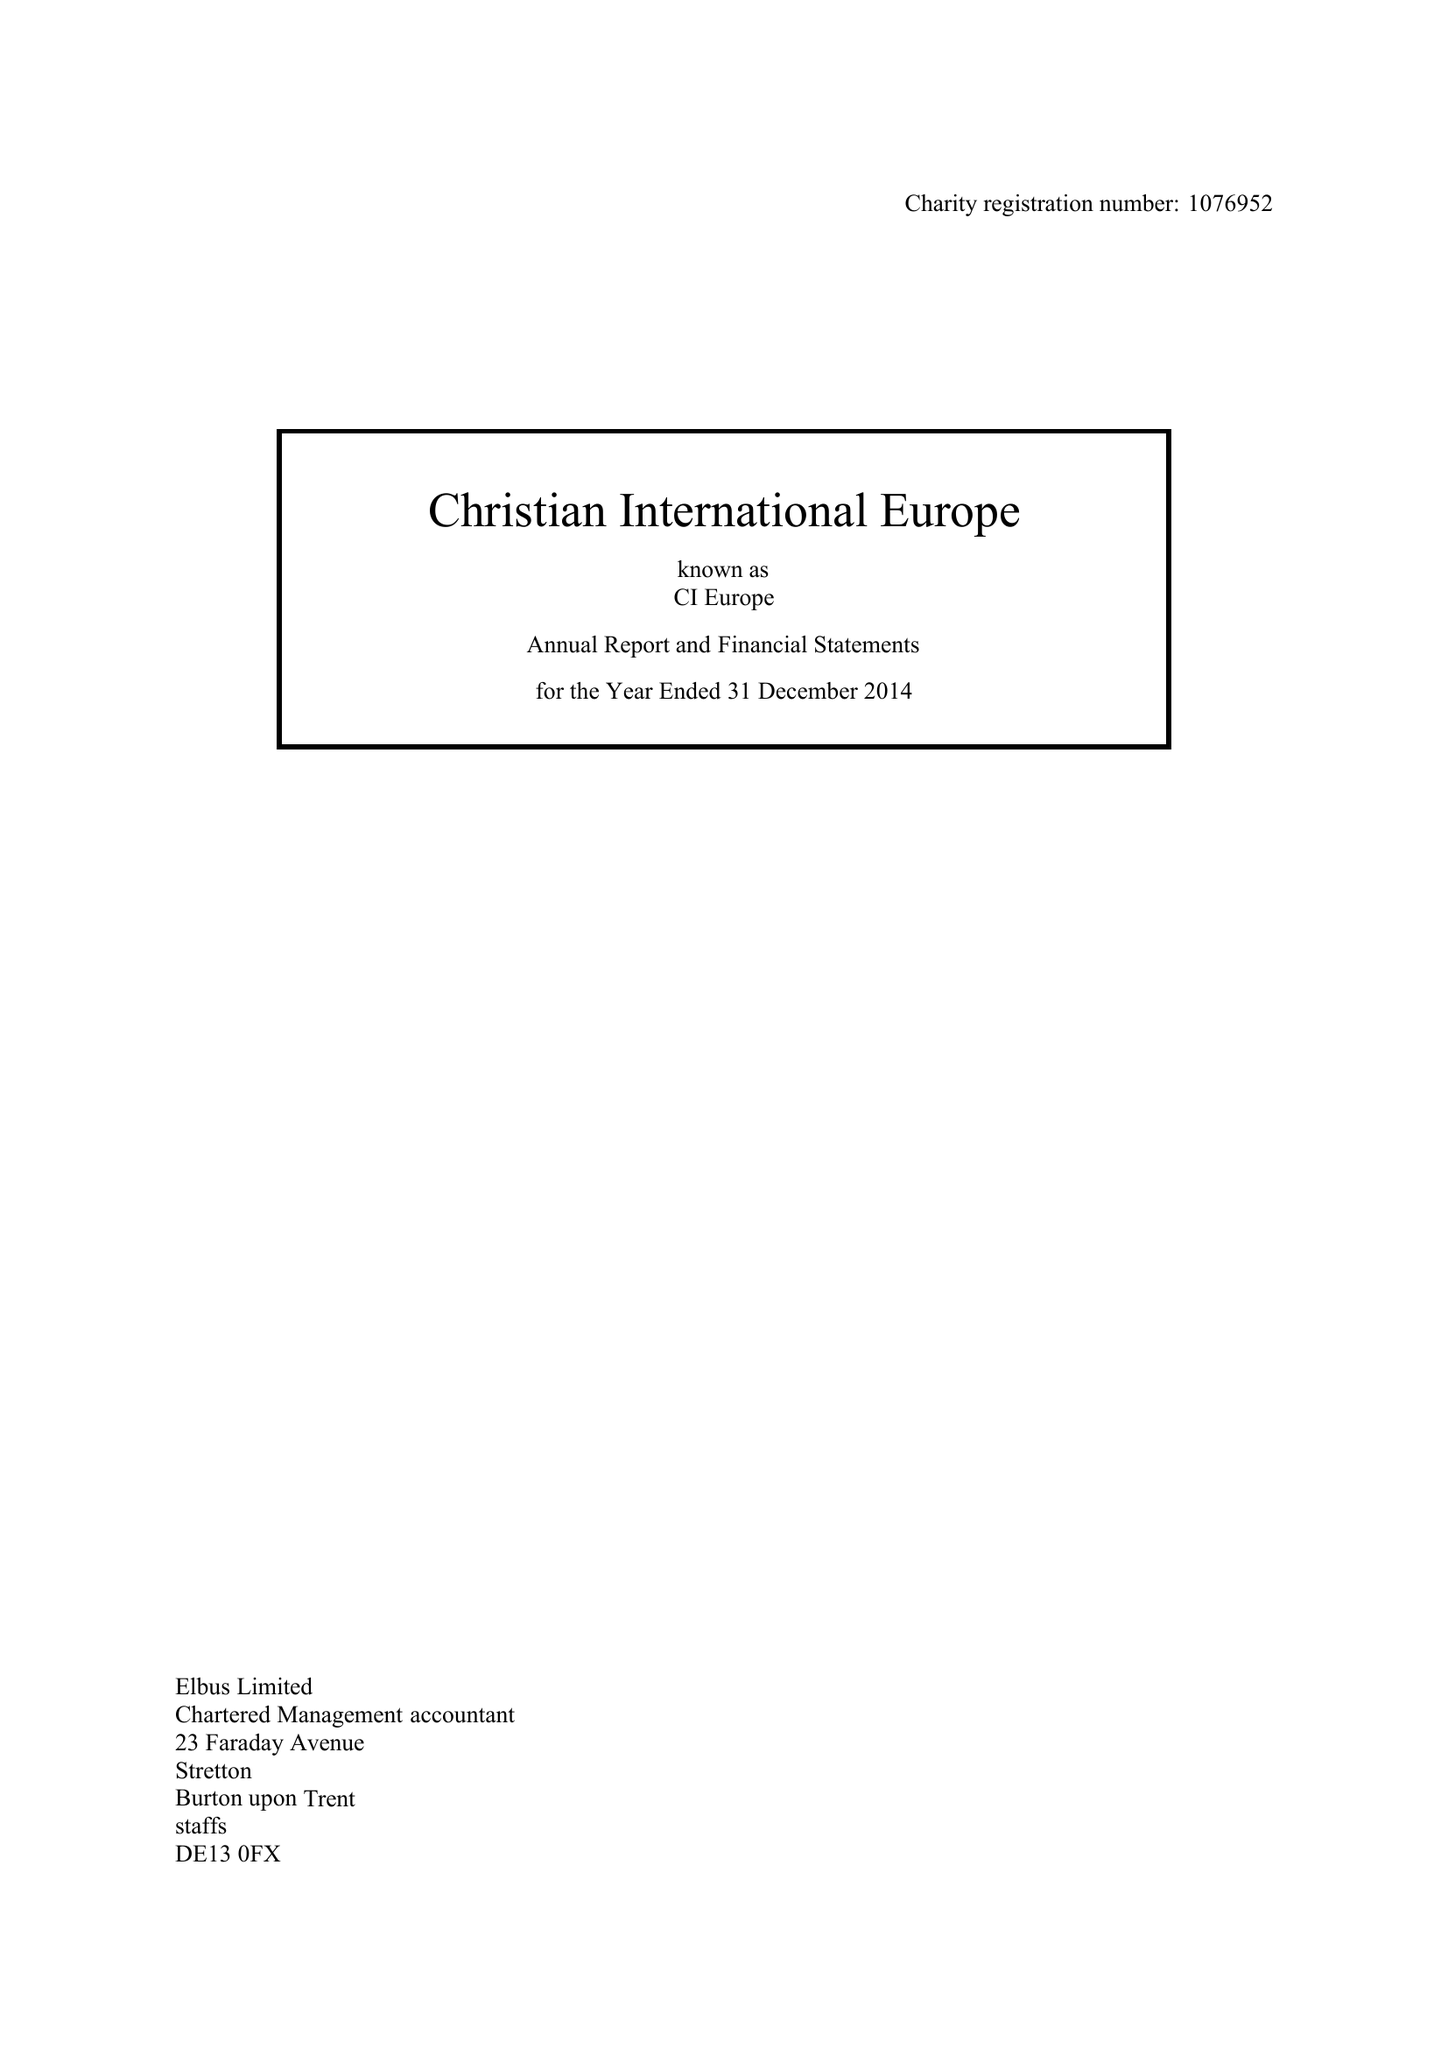What is the value for the spending_annually_in_british_pounds?
Answer the question using a single word or phrase. 115213.00 